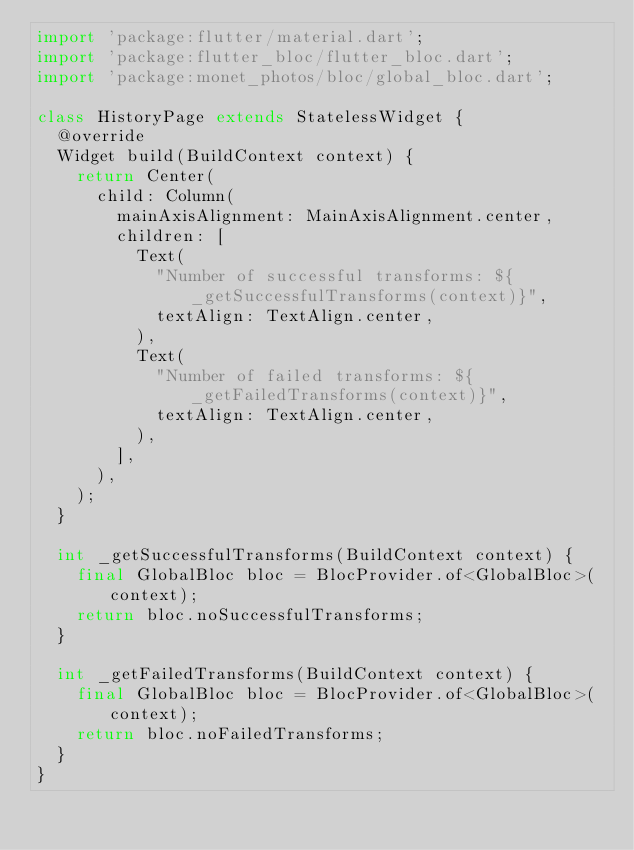Convert code to text. <code><loc_0><loc_0><loc_500><loc_500><_Dart_>import 'package:flutter/material.dart';
import 'package:flutter_bloc/flutter_bloc.dart';
import 'package:monet_photos/bloc/global_bloc.dart';

class HistoryPage extends StatelessWidget {
  @override
  Widget build(BuildContext context) {
    return Center(
      child: Column(
        mainAxisAlignment: MainAxisAlignment.center,
        children: [
          Text(
            "Number of successful transforms: ${_getSuccessfulTransforms(context)}",
            textAlign: TextAlign.center,
          ),
          Text(
            "Number of failed transforms: ${_getFailedTransforms(context)}",
            textAlign: TextAlign.center,
          ),
        ],
      ),
    );
  }

  int _getSuccessfulTransforms(BuildContext context) {
    final GlobalBloc bloc = BlocProvider.of<GlobalBloc>(context);
    return bloc.noSuccessfulTransforms;
  }

  int _getFailedTransforms(BuildContext context) {
    final GlobalBloc bloc = BlocProvider.of<GlobalBloc>(context);
    return bloc.noFailedTransforms;
  }
}
</code> 